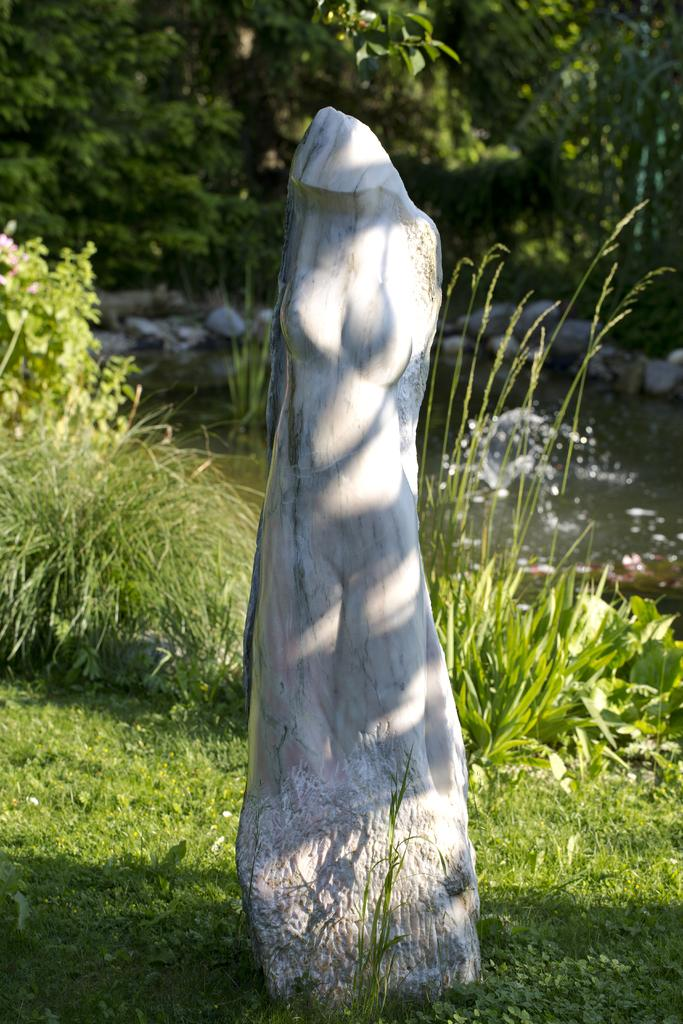What is the main subject of the image? There is a white color stone in the shape of a female in the image. Where is the stone located in the image? The stone is in the middle of the image. What can be seen on the right side of the image? There is water on the right side of the image. What type of vegetation is present in the image? There are trees in the image. What type of fang can be seen in the image? There is no fang present in the image. Can you describe the straw used to drink the water in the image? There is no straw visible in the image; it only shows water on the right side. 